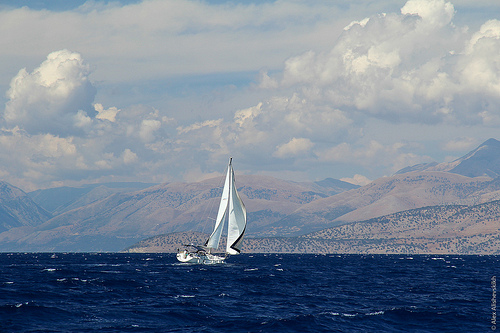Describe the environment surrounding the boat. The environment in the image is maritime. The sailboat is surrounded by open, deep blue waters, indicating it's likely in a large body of water like a sea or ocean. In the distance, there are mountainous landscapes which could suggest coastal regions. The clouds above suggest variability in the weather, which could lead to changing sailing conditions. 